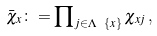Convert formula to latex. <formula><loc_0><loc_0><loc_500><loc_500>\bar { \chi } _ { x } \colon = \prod \nolimits _ { j \in \Lambda \ \{ x \} } \chi _ { x j } \, ,</formula> 